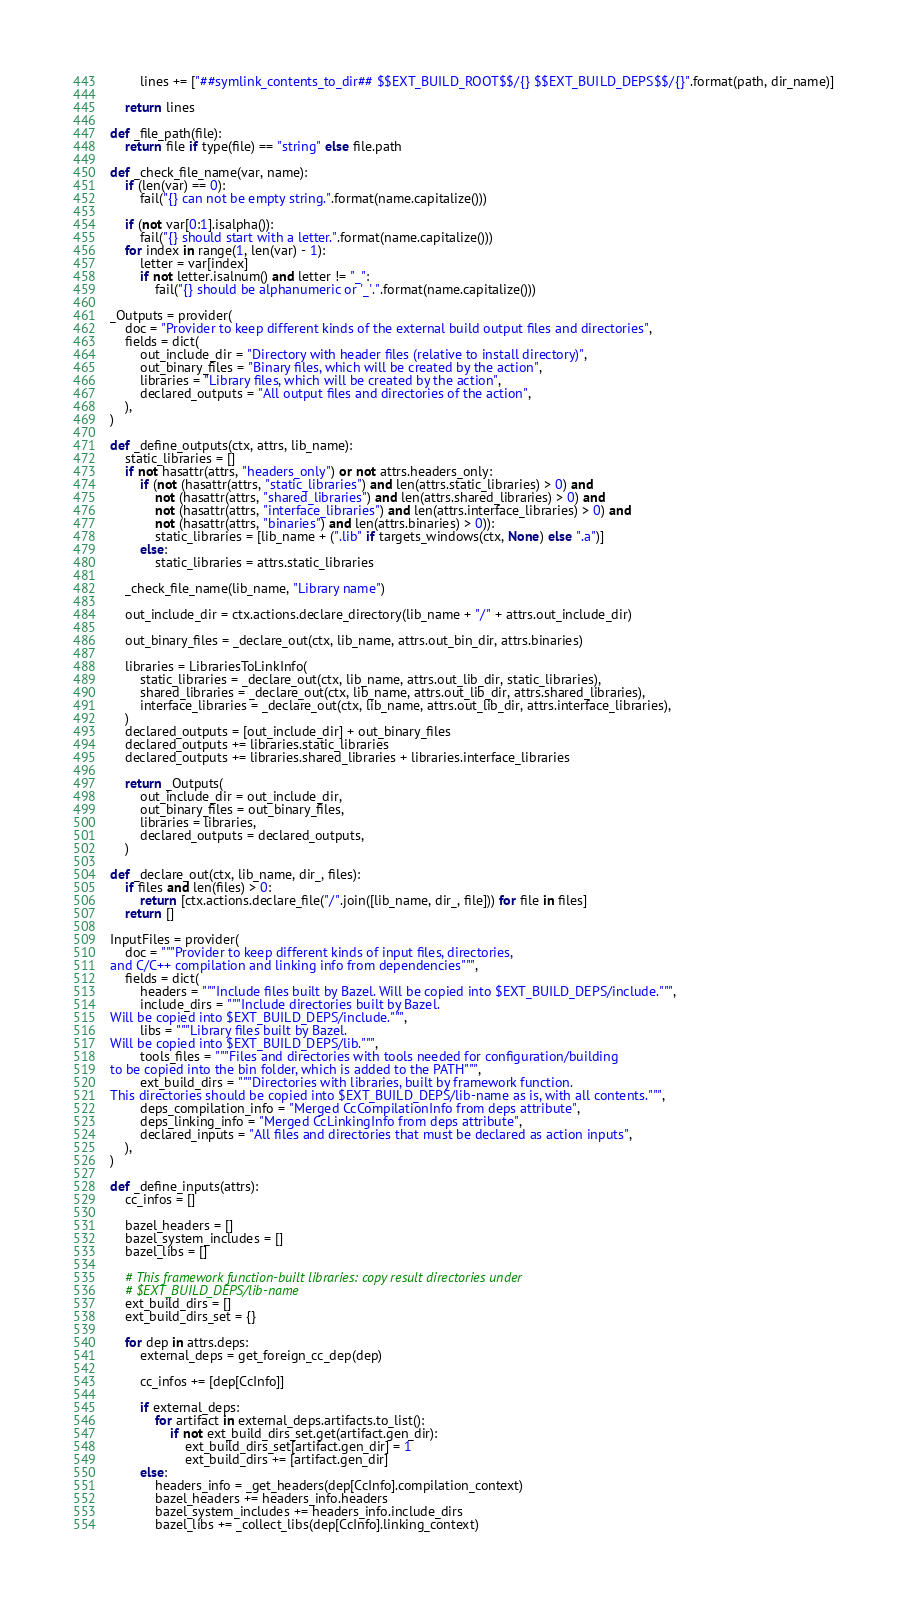<code> <loc_0><loc_0><loc_500><loc_500><_Python_>        lines += ["##symlink_contents_to_dir## $$EXT_BUILD_ROOT$$/{} $$EXT_BUILD_DEPS$$/{}".format(path, dir_name)]

    return lines

def _file_path(file):
    return file if type(file) == "string" else file.path

def _check_file_name(var, name):
    if (len(var) == 0):
        fail("{} can not be empty string.".format(name.capitalize()))

    if (not var[0:1].isalpha()):
        fail("{} should start with a letter.".format(name.capitalize()))
    for index in range(1, len(var) - 1):
        letter = var[index]
        if not letter.isalnum() and letter != "_":
            fail("{} should be alphanumeric or '_'.".format(name.capitalize()))

_Outputs = provider(
    doc = "Provider to keep different kinds of the external build output files and directories",
    fields = dict(
        out_include_dir = "Directory with header files (relative to install directory)",
        out_binary_files = "Binary files, which will be created by the action",
        libraries = "Library files, which will be created by the action",
        declared_outputs = "All output files and directories of the action",
    ),
)

def _define_outputs(ctx, attrs, lib_name):
    static_libraries = []
    if not hasattr(attrs, "headers_only") or not attrs.headers_only:
        if (not (hasattr(attrs, "static_libraries") and len(attrs.static_libraries) > 0) and
            not (hasattr(attrs, "shared_libraries") and len(attrs.shared_libraries) > 0) and
            not (hasattr(attrs, "interface_libraries") and len(attrs.interface_libraries) > 0) and
            not (hasattr(attrs, "binaries") and len(attrs.binaries) > 0)):
            static_libraries = [lib_name + (".lib" if targets_windows(ctx, None) else ".a")]
        else:
            static_libraries = attrs.static_libraries

    _check_file_name(lib_name, "Library name")

    out_include_dir = ctx.actions.declare_directory(lib_name + "/" + attrs.out_include_dir)

    out_binary_files = _declare_out(ctx, lib_name, attrs.out_bin_dir, attrs.binaries)

    libraries = LibrariesToLinkInfo(
        static_libraries = _declare_out(ctx, lib_name, attrs.out_lib_dir, static_libraries),
        shared_libraries = _declare_out(ctx, lib_name, attrs.out_lib_dir, attrs.shared_libraries),
        interface_libraries = _declare_out(ctx, lib_name, attrs.out_lib_dir, attrs.interface_libraries),
    )
    declared_outputs = [out_include_dir] + out_binary_files
    declared_outputs += libraries.static_libraries
    declared_outputs += libraries.shared_libraries + libraries.interface_libraries

    return _Outputs(
        out_include_dir = out_include_dir,
        out_binary_files = out_binary_files,
        libraries = libraries,
        declared_outputs = declared_outputs,
    )

def _declare_out(ctx, lib_name, dir_, files):
    if files and len(files) > 0:
        return [ctx.actions.declare_file("/".join([lib_name, dir_, file])) for file in files]
    return []

InputFiles = provider(
    doc = """Provider to keep different kinds of input files, directories,
and C/C++ compilation and linking info from dependencies""",
    fields = dict(
        headers = """Include files built by Bazel. Will be copied into $EXT_BUILD_DEPS/include.""",
        include_dirs = """Include directories built by Bazel.
Will be copied into $EXT_BUILD_DEPS/include.""",
        libs = """Library files built by Bazel.
Will be copied into $EXT_BUILD_DEPS/lib.""",
        tools_files = """Files and directories with tools needed for configuration/building
to be copied into the bin folder, which is added to the PATH""",
        ext_build_dirs = """Directories with libraries, built by framework function.
This directories should be copied into $EXT_BUILD_DEPS/lib-name as is, with all contents.""",
        deps_compilation_info = "Merged CcCompilationInfo from deps attribute",
        deps_linking_info = "Merged CcLinkingInfo from deps attribute",
        declared_inputs = "All files and directories that must be declared as action inputs",
    ),
)

def _define_inputs(attrs):
    cc_infos = []

    bazel_headers = []
    bazel_system_includes = []
    bazel_libs = []

    # This framework function-built libraries: copy result directories under
    # $EXT_BUILD_DEPS/lib-name
    ext_build_dirs = []
    ext_build_dirs_set = {}

    for dep in attrs.deps:
        external_deps = get_foreign_cc_dep(dep)

        cc_infos += [dep[CcInfo]]

        if external_deps:
            for artifact in external_deps.artifacts.to_list():
                if not ext_build_dirs_set.get(artifact.gen_dir):
                    ext_build_dirs_set[artifact.gen_dir] = 1
                    ext_build_dirs += [artifact.gen_dir]
        else:
            headers_info = _get_headers(dep[CcInfo].compilation_context)
            bazel_headers += headers_info.headers
            bazel_system_includes += headers_info.include_dirs
            bazel_libs += _collect_libs(dep[CcInfo].linking_context)
</code> 